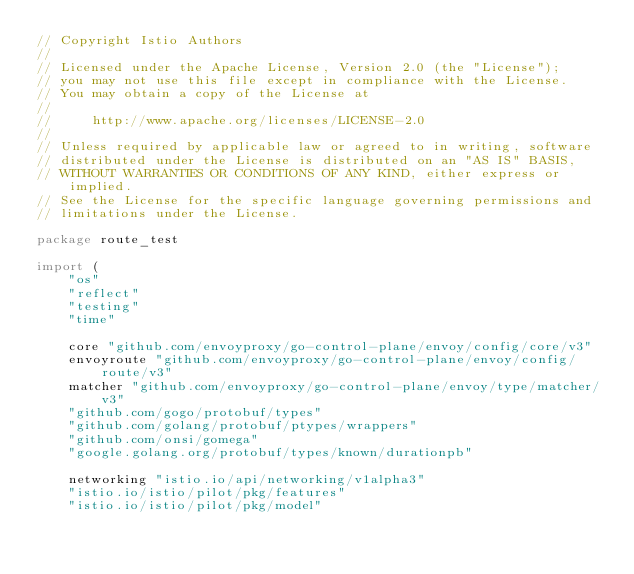<code> <loc_0><loc_0><loc_500><loc_500><_Go_>// Copyright Istio Authors
//
// Licensed under the Apache License, Version 2.0 (the "License");
// you may not use this file except in compliance with the License.
// You may obtain a copy of the License at
//
//     http://www.apache.org/licenses/LICENSE-2.0
//
// Unless required by applicable law or agreed to in writing, software
// distributed under the License is distributed on an "AS IS" BASIS,
// WITHOUT WARRANTIES OR CONDITIONS OF ANY KIND, either express or implied.
// See the License for the specific language governing permissions and
// limitations under the License.

package route_test

import (
	"os"
	"reflect"
	"testing"
	"time"

	core "github.com/envoyproxy/go-control-plane/envoy/config/core/v3"
	envoyroute "github.com/envoyproxy/go-control-plane/envoy/config/route/v3"
	matcher "github.com/envoyproxy/go-control-plane/envoy/type/matcher/v3"
	"github.com/gogo/protobuf/types"
	"github.com/golang/protobuf/ptypes/wrappers"
	"github.com/onsi/gomega"
	"google.golang.org/protobuf/types/known/durationpb"

	networking "istio.io/api/networking/v1alpha3"
	"istio.io/istio/pilot/pkg/features"
	"istio.io/istio/pilot/pkg/model"</code> 